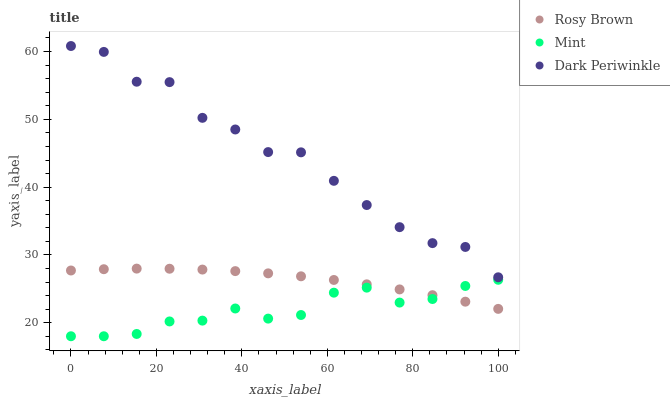Does Mint have the minimum area under the curve?
Answer yes or no. Yes. Does Dark Periwinkle have the maximum area under the curve?
Answer yes or no. Yes. Does Dark Periwinkle have the minimum area under the curve?
Answer yes or no. No. Does Mint have the maximum area under the curve?
Answer yes or no. No. Is Rosy Brown the smoothest?
Answer yes or no. Yes. Is Dark Periwinkle the roughest?
Answer yes or no. Yes. Is Mint the smoothest?
Answer yes or no. No. Is Mint the roughest?
Answer yes or no. No. Does Mint have the lowest value?
Answer yes or no. Yes. Does Dark Periwinkle have the lowest value?
Answer yes or no. No. Does Dark Periwinkle have the highest value?
Answer yes or no. Yes. Does Mint have the highest value?
Answer yes or no. No. Is Mint less than Dark Periwinkle?
Answer yes or no. Yes. Is Dark Periwinkle greater than Mint?
Answer yes or no. Yes. Does Mint intersect Rosy Brown?
Answer yes or no. Yes. Is Mint less than Rosy Brown?
Answer yes or no. No. Is Mint greater than Rosy Brown?
Answer yes or no. No. Does Mint intersect Dark Periwinkle?
Answer yes or no. No. 